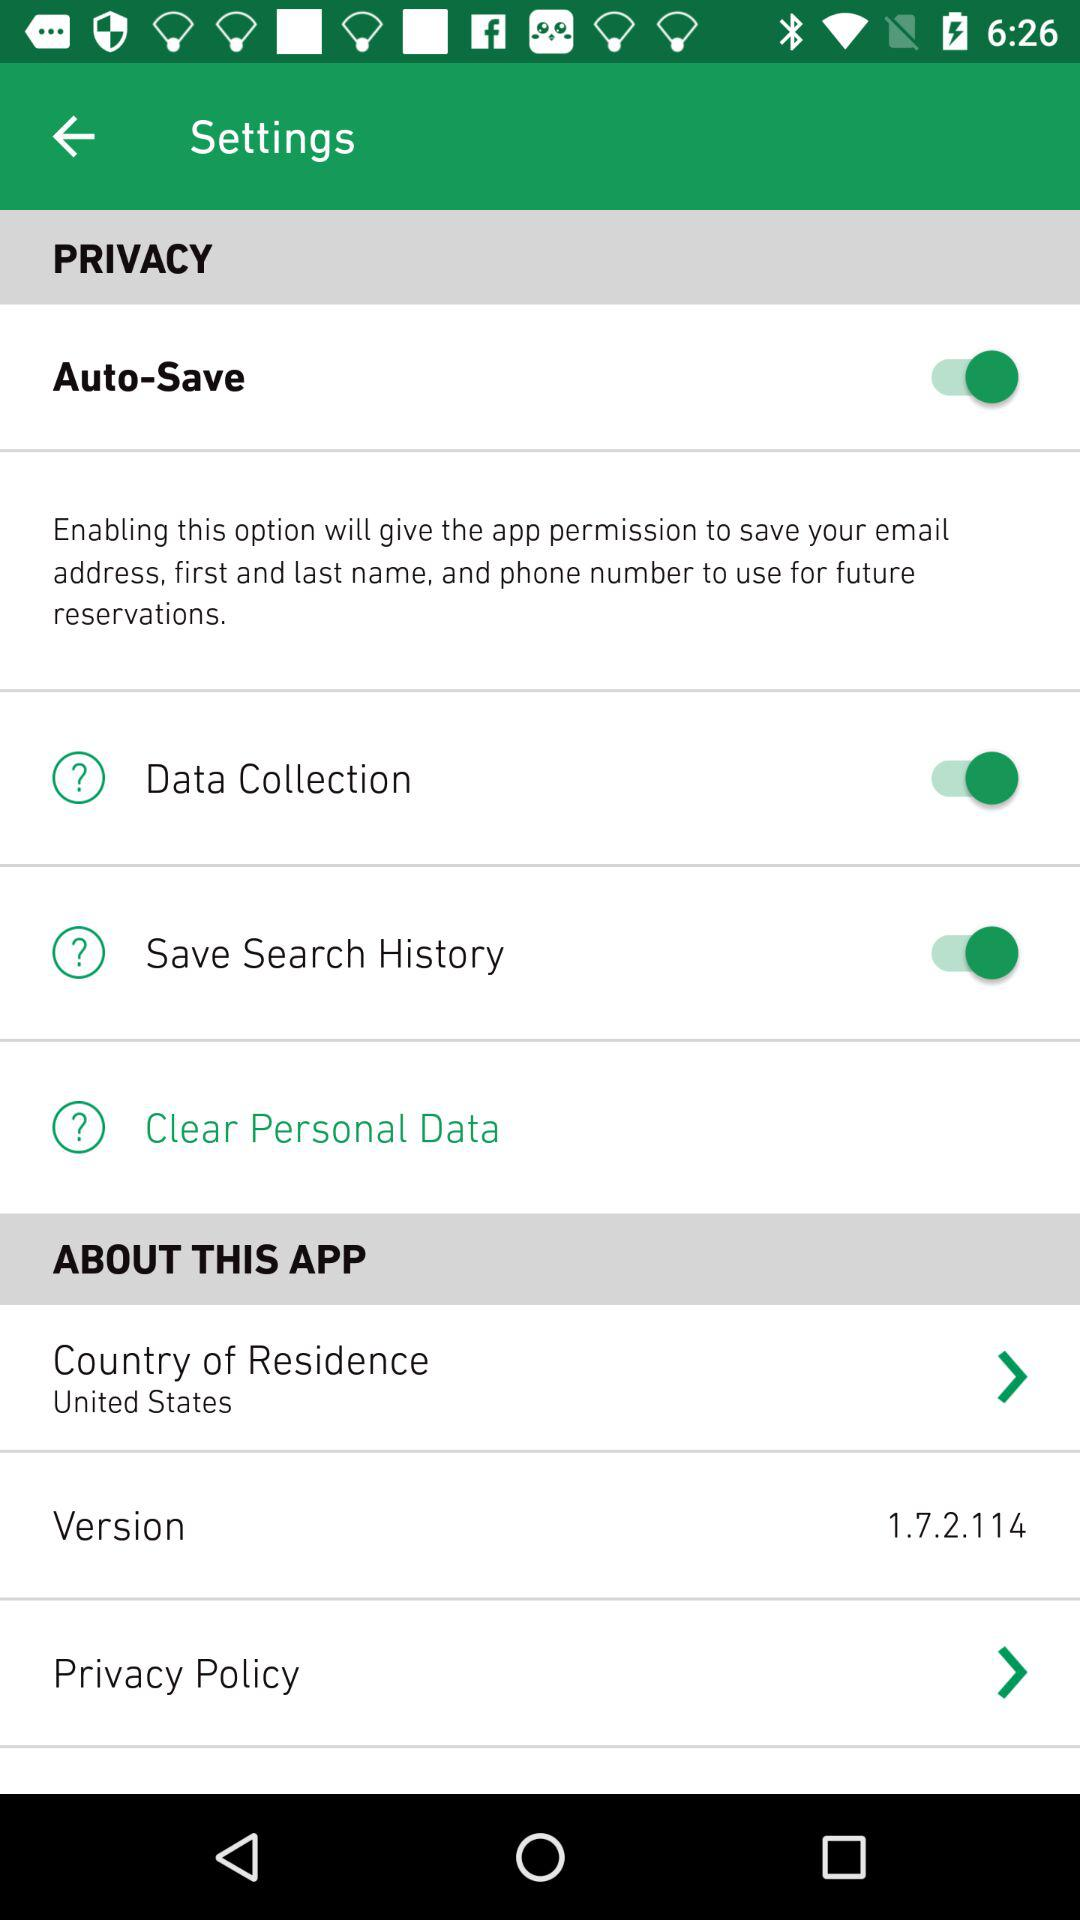What is the status of "Data Collection"? The status is "on". 